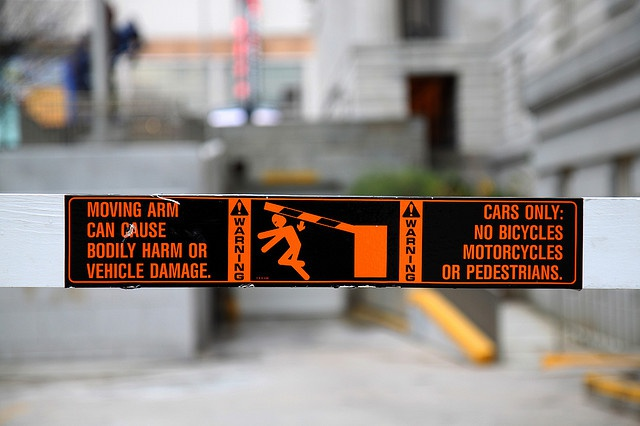Describe the objects in this image and their specific colors. I can see various objects in this image with different colors. 